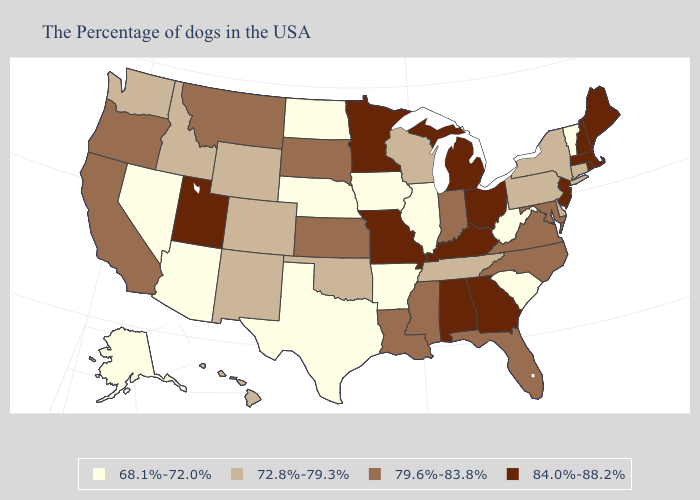Does Rhode Island have a lower value than Kentucky?
Quick response, please. No. Does Mississippi have a lower value than Wyoming?
Give a very brief answer. No. Name the states that have a value in the range 72.8%-79.3%?
Write a very short answer. Connecticut, New York, Delaware, Pennsylvania, Tennessee, Wisconsin, Oklahoma, Wyoming, Colorado, New Mexico, Idaho, Washington, Hawaii. Name the states that have a value in the range 84.0%-88.2%?
Give a very brief answer. Maine, Massachusetts, Rhode Island, New Hampshire, New Jersey, Ohio, Georgia, Michigan, Kentucky, Alabama, Missouri, Minnesota, Utah. What is the lowest value in states that border Maine?
Write a very short answer. 84.0%-88.2%. Does Nebraska have the lowest value in the USA?
Be succinct. Yes. Among the states that border Arizona , does New Mexico have the lowest value?
Be succinct. No. What is the value of Alabama?
Answer briefly. 84.0%-88.2%. What is the value of Connecticut?
Keep it brief. 72.8%-79.3%. Name the states that have a value in the range 68.1%-72.0%?
Be succinct. Vermont, South Carolina, West Virginia, Illinois, Arkansas, Iowa, Nebraska, Texas, North Dakota, Arizona, Nevada, Alaska. Among the states that border Rhode Island , does Connecticut have the highest value?
Short answer required. No. What is the value of New Jersey?
Give a very brief answer. 84.0%-88.2%. Name the states that have a value in the range 79.6%-83.8%?
Give a very brief answer. Maryland, Virginia, North Carolina, Florida, Indiana, Mississippi, Louisiana, Kansas, South Dakota, Montana, California, Oregon. Among the states that border Oregon , which have the highest value?
Keep it brief. California. Does California have the same value as Vermont?
Write a very short answer. No. 